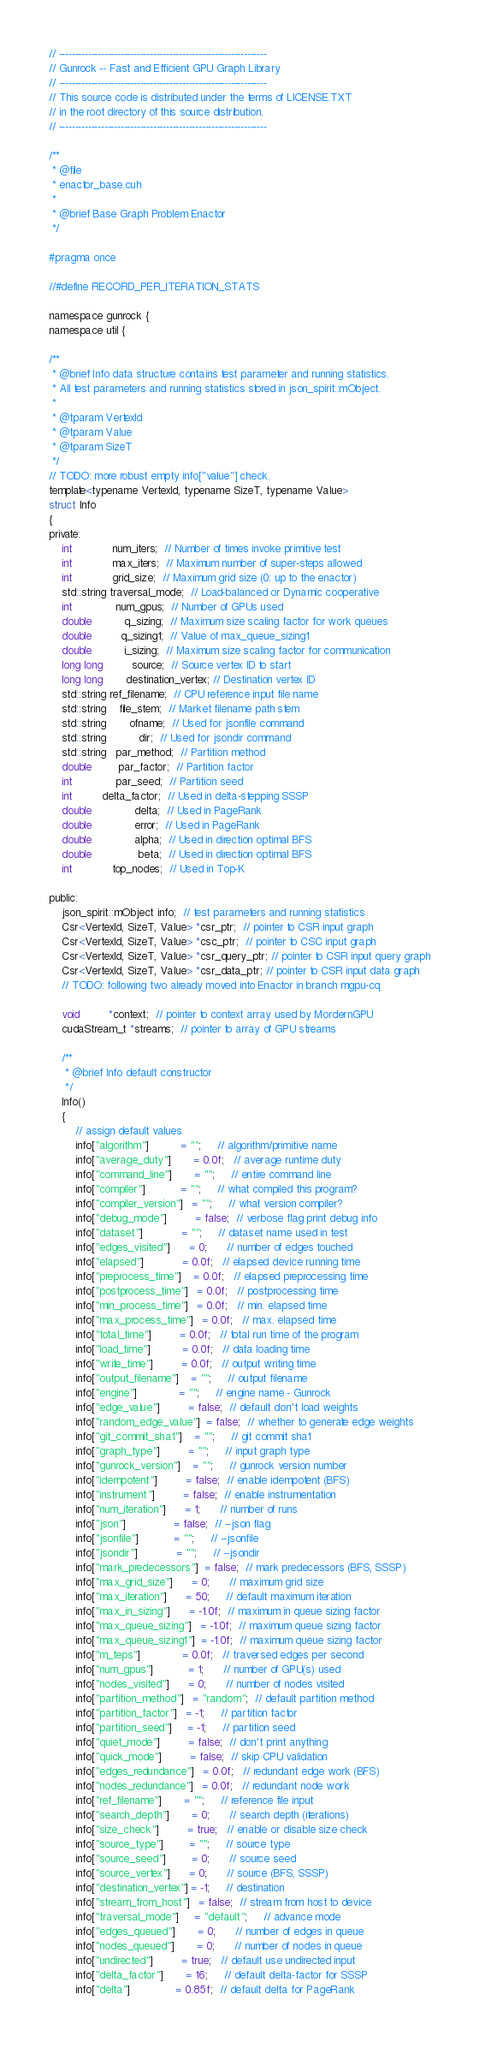<code> <loc_0><loc_0><loc_500><loc_500><_Cuda_>// ----------------------------------------------------------------
// Gunrock -- Fast and Efficient GPU Graph Library
// ----------------------------------------------------------------
// This source code is distributed under the terms of LICENSE.TXT
// in the root directory of this source distribution.
// ----------------------------------------------------------------

/**
 * @file
 * enactor_base.cuh
 *
 * @brief Base Graph Problem Enactor
 */

#pragma once

//#define RECORD_PER_ITERATION_STATS

namespace gunrock {
namespace util {

/**
 * @brief Info data structure contains test parameter and running statistics.
 * All test parameters and running statistics stored in json_spirit::mObject.
 *
 * @tparam VertexId
 * @tparam Value
 * @tparam SizeT
 */
// TODO: more robust empty info["value"] check.
template<typename VertexId, typename SizeT, typename Value>
struct Info
{
private:
    int            num_iters;  // Number of times invoke primitive test
    int            max_iters;  // Maximum number of super-steps allowed
    int            grid_size;  // Maximum grid size (0: up to the enactor)
    std::string traversal_mode;  // Load-balanced or Dynamic cooperative
    int             num_gpus;  // Number of GPUs used
    double          q_sizing;  // Maximum size scaling factor for work queues
    double         q_sizing1;  // Value of max_queue_sizing1
    double          i_sizing;  // Maximum size scaling factor for communication
    long long         source;  // Source vertex ID to start
    long long       destination_vertex; // Destination vertex ID
    std::string ref_filename;  // CPU reference input file name
    std::string    file_stem;  // Market filename path stem
    std::string       ofname;  // Used for jsonfile command
    std::string          dir;  // Used for jsondir command
    std::string   par_method;  // Partition method
    double        par_factor;  // Partition factor
    int             par_seed;  // Partition seed
    int         delta_factor;  // Used in delta-stepping SSSP
    double             delta;  // Used in PageRank
    double             error;  // Used in PageRank
    double             alpha;  // Used in direction optimal BFS
    double              beta;  // Used in direction optimal BFS
    int            top_nodes;  // Used in Top-K

public:
    json_spirit::mObject info;  // test parameters and running statistics
    Csr<VertexId, SizeT, Value> *csr_ptr;  // pointer to CSR input graph
    Csr<VertexId, SizeT, Value> *csc_ptr;  // pointer to CSC input graph
    Csr<VertexId, SizeT, Value> *csr_query_ptr; // pointer to CSR input query graph
    Csr<VertexId, SizeT, Value> *csr_data_ptr; // pointer to CSR input data graph
    // TODO: following two already moved into Enactor in branch mgpu-cq

    void         *context;  // pointer to context array used by MordernGPU
    cudaStream_t *streams;  // pointer to array of GPU streams

    /**
     * @brief Info default constructor
     */
    Info()
    {
        // assign default values
        info["algorithm"]          = "";     // algorithm/primitive name
        info["average_duty"]       = 0.0f;   // average runtime duty
        info["command_line"]       = "";     // entire command line
        info["compiler"]           = "";     // what compiled this program?
        info["compiler_version"]   = "";     // what version compiler?
        info["debug_mode"]         = false;  // verbose flag print debug info
        info["dataset"]            = "";     // dataset name used in test
        info["edges_visited"]      = 0;      // number of edges touched
        info["elapsed"]            = 0.0f;   // elapsed device running time
        info["preprocess_time"]    = 0.0f;   // elapsed preprocessing time
        info["postprocess_time"]   = 0.0f;   // postprocessing time
        info["min_process_time"]   = 0.0f;   // min. elapsed time
        info["max_process_time"]   = 0.0f;   // max. elapsed time
        info["total_time"]         = 0.0f;   // total run time of the program
        info["load_time"]          = 0.0f;   // data loading time
        info["write_time"]         = 0.0f;   // output writing time
        info["output_filename"]    = "";     // output filename
        info["engine"]             = "";     // engine name - Gunrock
        info["edge_value"]         = false;  // default don't load weights
        info["random_edge_value"]  = false;  // whether to generate edge weights
        info["git_commit_sha1"]    = "";     // git commit sha1
        info["graph_type"]         = "";     // input graph type
        info["gunrock_version"]    = "";     // gunrock version number
        info["idempotent"]         = false;  // enable idempotent (BFS)
        info["instrument"]         = false;  // enable instrumentation
        info["num_iteration"]      = 1;      // number of runs
        info["json"]               = false;  // --json flag
        info["jsonfile"]           = "";     // --jsonfile
        info["jsondir"]            = "";     // --jsondir
        info["mark_predecessors"]  = false;  // mark predecessors (BFS, SSSP)
        info["max_grid_size"]      = 0;      // maximum grid size
        info["max_iteration"]      = 50;     // default maximum iteration
        info["max_in_sizing"]      = -1.0f;  // maximum in queue sizing factor
        info["max_queue_sizing"]   = -1.0f;  // maximum queue sizing factor
        info["max_queue_sizing1"]  = -1.0f;  // maximum queue sizing factor
        info["m_teps"]             = 0.0f;   // traversed edges per second
        info["num_gpus"]           = 1;      // number of GPU(s) used
        info["nodes_visited"]      = 0;      // number of nodes visited
        info["partition_method"]   = "random";  // default partition method
        info["partition_factor"]   = -1;     // partition factor
        info["partition_seed"]     = -1;     // partition seed
        info["quiet_mode"]         = false;  // don't print anything
        info["quick_mode"]         = false;  // skip CPU validation
        info["edges_redundance"]   = 0.0f;   // redundant edge work (BFS)
        info["nodes_redundance"]   = 0.0f;   // redundant node work
        info["ref_filename"]       = "";     // reference file input
        info["search_depth"]       = 0;      // search depth (iterations)
        info["size_check"]         = true;   // enable or disable size check
        info["source_type"]        = "";     // source type
        info["source_seed"]        = 0;      // source seed
        info["source_vertex"]      = 0;      // source (BFS, SSSP)
        info["destination_vertex"] = -1;     // destination
        info["stream_from_host"]   = false;  // stream from host to device
        info["traversal_mode"]     = "default";     // advance mode
        info["edges_queued"]       = 0;      // number of edges in queue
        info["nodes_queued"]       = 0;      // number of nodes in queue
        info["undirected"]         = true;   // default use undirected input
        info["delta_factor"]       = 16;     // default delta-factor for SSSP
        info["delta"]              = 0.85f;  // default delta for PageRank</code> 